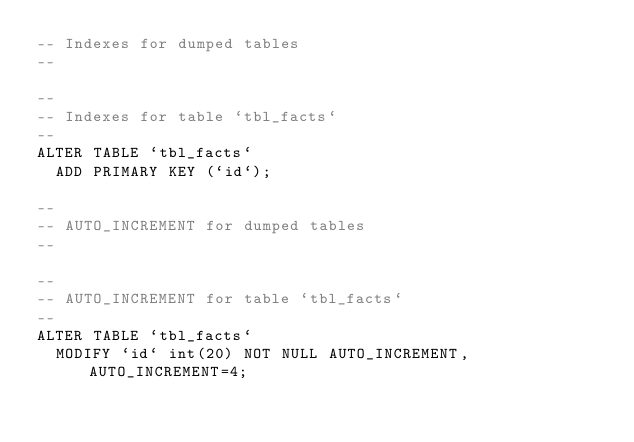<code> <loc_0><loc_0><loc_500><loc_500><_SQL_>-- Indexes for dumped tables
--

--
-- Indexes for table `tbl_facts`
--
ALTER TABLE `tbl_facts`
  ADD PRIMARY KEY (`id`);

--
-- AUTO_INCREMENT for dumped tables
--

--
-- AUTO_INCREMENT for table `tbl_facts`
--
ALTER TABLE `tbl_facts`
  MODIFY `id` int(20) NOT NULL AUTO_INCREMENT, AUTO_INCREMENT=4;
</code> 